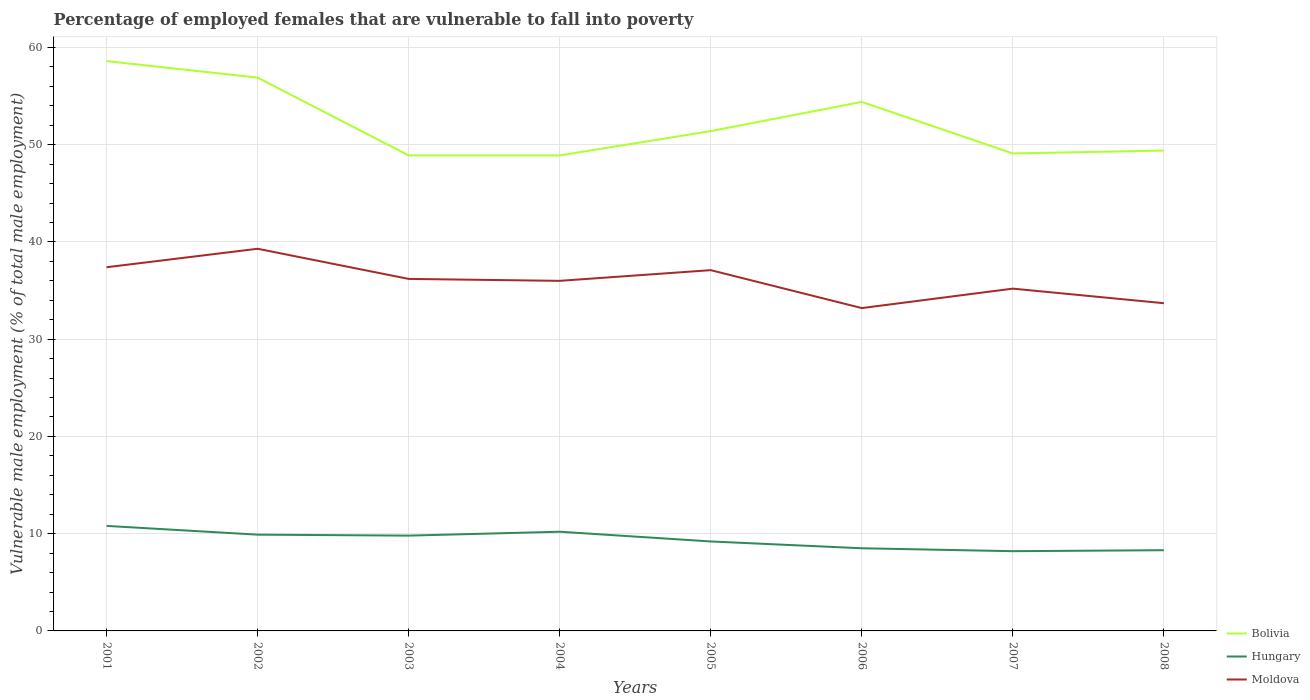Across all years, what is the maximum percentage of employed females who are vulnerable to fall into poverty in Hungary?
Keep it short and to the point. 8.2. In which year was the percentage of employed females who are vulnerable to fall into poverty in Bolivia maximum?
Make the answer very short. 2003. What is the total percentage of employed females who are vulnerable to fall into poverty in Bolivia in the graph?
Your answer should be very brief. 9.7. What is the difference between the highest and the second highest percentage of employed females who are vulnerable to fall into poverty in Moldova?
Your response must be concise. 6.1. What is the difference between the highest and the lowest percentage of employed females who are vulnerable to fall into poverty in Bolivia?
Offer a very short reply. 3. How many lines are there?
Provide a succinct answer. 3. What is the difference between two consecutive major ticks on the Y-axis?
Your answer should be very brief. 10. Are the values on the major ticks of Y-axis written in scientific E-notation?
Offer a very short reply. No. Does the graph contain grids?
Provide a succinct answer. Yes. Where does the legend appear in the graph?
Keep it short and to the point. Bottom right. How many legend labels are there?
Your answer should be very brief. 3. What is the title of the graph?
Keep it short and to the point. Percentage of employed females that are vulnerable to fall into poverty. Does "Bangladesh" appear as one of the legend labels in the graph?
Offer a very short reply. No. What is the label or title of the X-axis?
Provide a succinct answer. Years. What is the label or title of the Y-axis?
Your response must be concise. Vulnerable male employment (% of total male employment). What is the Vulnerable male employment (% of total male employment) of Bolivia in 2001?
Your answer should be very brief. 58.6. What is the Vulnerable male employment (% of total male employment) in Hungary in 2001?
Your response must be concise. 10.8. What is the Vulnerable male employment (% of total male employment) in Moldova in 2001?
Provide a succinct answer. 37.4. What is the Vulnerable male employment (% of total male employment) of Bolivia in 2002?
Offer a very short reply. 56.9. What is the Vulnerable male employment (% of total male employment) of Hungary in 2002?
Offer a very short reply. 9.9. What is the Vulnerable male employment (% of total male employment) of Moldova in 2002?
Offer a very short reply. 39.3. What is the Vulnerable male employment (% of total male employment) of Bolivia in 2003?
Your answer should be compact. 48.9. What is the Vulnerable male employment (% of total male employment) in Hungary in 2003?
Your response must be concise. 9.8. What is the Vulnerable male employment (% of total male employment) in Moldova in 2003?
Provide a short and direct response. 36.2. What is the Vulnerable male employment (% of total male employment) in Bolivia in 2004?
Your answer should be very brief. 48.9. What is the Vulnerable male employment (% of total male employment) of Hungary in 2004?
Keep it short and to the point. 10.2. What is the Vulnerable male employment (% of total male employment) of Bolivia in 2005?
Your answer should be very brief. 51.4. What is the Vulnerable male employment (% of total male employment) in Hungary in 2005?
Keep it short and to the point. 9.2. What is the Vulnerable male employment (% of total male employment) in Moldova in 2005?
Provide a succinct answer. 37.1. What is the Vulnerable male employment (% of total male employment) of Bolivia in 2006?
Provide a short and direct response. 54.4. What is the Vulnerable male employment (% of total male employment) in Hungary in 2006?
Offer a terse response. 8.5. What is the Vulnerable male employment (% of total male employment) in Moldova in 2006?
Your answer should be compact. 33.2. What is the Vulnerable male employment (% of total male employment) in Bolivia in 2007?
Offer a terse response. 49.1. What is the Vulnerable male employment (% of total male employment) in Hungary in 2007?
Offer a very short reply. 8.2. What is the Vulnerable male employment (% of total male employment) in Moldova in 2007?
Your answer should be very brief. 35.2. What is the Vulnerable male employment (% of total male employment) of Bolivia in 2008?
Offer a very short reply. 49.4. What is the Vulnerable male employment (% of total male employment) in Hungary in 2008?
Keep it short and to the point. 8.3. What is the Vulnerable male employment (% of total male employment) of Moldova in 2008?
Your response must be concise. 33.7. Across all years, what is the maximum Vulnerable male employment (% of total male employment) of Bolivia?
Your answer should be very brief. 58.6. Across all years, what is the maximum Vulnerable male employment (% of total male employment) in Hungary?
Your answer should be very brief. 10.8. Across all years, what is the maximum Vulnerable male employment (% of total male employment) in Moldova?
Make the answer very short. 39.3. Across all years, what is the minimum Vulnerable male employment (% of total male employment) in Bolivia?
Provide a succinct answer. 48.9. Across all years, what is the minimum Vulnerable male employment (% of total male employment) in Hungary?
Provide a succinct answer. 8.2. Across all years, what is the minimum Vulnerable male employment (% of total male employment) of Moldova?
Your answer should be very brief. 33.2. What is the total Vulnerable male employment (% of total male employment) in Bolivia in the graph?
Make the answer very short. 417.6. What is the total Vulnerable male employment (% of total male employment) in Hungary in the graph?
Your response must be concise. 74.9. What is the total Vulnerable male employment (% of total male employment) of Moldova in the graph?
Offer a very short reply. 288.1. What is the difference between the Vulnerable male employment (% of total male employment) of Hungary in 2001 and that in 2002?
Your answer should be compact. 0.9. What is the difference between the Vulnerable male employment (% of total male employment) of Hungary in 2001 and that in 2003?
Your response must be concise. 1. What is the difference between the Vulnerable male employment (% of total male employment) of Moldova in 2001 and that in 2003?
Provide a short and direct response. 1.2. What is the difference between the Vulnerable male employment (% of total male employment) in Bolivia in 2001 and that in 2004?
Your response must be concise. 9.7. What is the difference between the Vulnerable male employment (% of total male employment) of Hungary in 2001 and that in 2004?
Keep it short and to the point. 0.6. What is the difference between the Vulnerable male employment (% of total male employment) of Bolivia in 2001 and that in 2005?
Ensure brevity in your answer.  7.2. What is the difference between the Vulnerable male employment (% of total male employment) in Hungary in 2001 and that in 2006?
Ensure brevity in your answer.  2.3. What is the difference between the Vulnerable male employment (% of total male employment) of Moldova in 2001 and that in 2007?
Your answer should be very brief. 2.2. What is the difference between the Vulnerable male employment (% of total male employment) in Moldova in 2001 and that in 2008?
Make the answer very short. 3.7. What is the difference between the Vulnerable male employment (% of total male employment) of Bolivia in 2002 and that in 2004?
Your answer should be compact. 8. What is the difference between the Vulnerable male employment (% of total male employment) in Hungary in 2002 and that in 2004?
Offer a terse response. -0.3. What is the difference between the Vulnerable male employment (% of total male employment) of Moldova in 2002 and that in 2004?
Ensure brevity in your answer.  3.3. What is the difference between the Vulnerable male employment (% of total male employment) in Hungary in 2002 and that in 2005?
Offer a terse response. 0.7. What is the difference between the Vulnerable male employment (% of total male employment) in Moldova in 2002 and that in 2005?
Ensure brevity in your answer.  2.2. What is the difference between the Vulnerable male employment (% of total male employment) of Bolivia in 2002 and that in 2006?
Provide a short and direct response. 2.5. What is the difference between the Vulnerable male employment (% of total male employment) in Moldova in 2002 and that in 2006?
Offer a terse response. 6.1. What is the difference between the Vulnerable male employment (% of total male employment) of Bolivia in 2002 and that in 2007?
Provide a short and direct response. 7.8. What is the difference between the Vulnerable male employment (% of total male employment) in Hungary in 2002 and that in 2007?
Ensure brevity in your answer.  1.7. What is the difference between the Vulnerable male employment (% of total male employment) in Hungary in 2002 and that in 2008?
Your response must be concise. 1.6. What is the difference between the Vulnerable male employment (% of total male employment) in Moldova in 2003 and that in 2004?
Ensure brevity in your answer.  0.2. What is the difference between the Vulnerable male employment (% of total male employment) in Bolivia in 2003 and that in 2005?
Offer a terse response. -2.5. What is the difference between the Vulnerable male employment (% of total male employment) of Hungary in 2003 and that in 2005?
Offer a terse response. 0.6. What is the difference between the Vulnerable male employment (% of total male employment) in Moldova in 2003 and that in 2005?
Offer a terse response. -0.9. What is the difference between the Vulnerable male employment (% of total male employment) of Bolivia in 2003 and that in 2006?
Give a very brief answer. -5.5. What is the difference between the Vulnerable male employment (% of total male employment) in Hungary in 2003 and that in 2007?
Provide a succinct answer. 1.6. What is the difference between the Vulnerable male employment (% of total male employment) of Moldova in 2003 and that in 2007?
Give a very brief answer. 1. What is the difference between the Vulnerable male employment (% of total male employment) in Bolivia in 2003 and that in 2008?
Keep it short and to the point. -0.5. What is the difference between the Vulnerable male employment (% of total male employment) in Hungary in 2003 and that in 2008?
Your response must be concise. 1.5. What is the difference between the Vulnerable male employment (% of total male employment) in Bolivia in 2004 and that in 2005?
Give a very brief answer. -2.5. What is the difference between the Vulnerable male employment (% of total male employment) in Hungary in 2004 and that in 2005?
Your answer should be very brief. 1. What is the difference between the Vulnerable male employment (% of total male employment) of Moldova in 2004 and that in 2005?
Give a very brief answer. -1.1. What is the difference between the Vulnerable male employment (% of total male employment) in Bolivia in 2004 and that in 2006?
Your response must be concise. -5.5. What is the difference between the Vulnerable male employment (% of total male employment) in Hungary in 2004 and that in 2006?
Your response must be concise. 1.7. What is the difference between the Vulnerable male employment (% of total male employment) of Moldova in 2004 and that in 2007?
Your response must be concise. 0.8. What is the difference between the Vulnerable male employment (% of total male employment) of Hungary in 2004 and that in 2008?
Provide a short and direct response. 1.9. What is the difference between the Vulnerable male employment (% of total male employment) of Moldova in 2004 and that in 2008?
Give a very brief answer. 2.3. What is the difference between the Vulnerable male employment (% of total male employment) of Hungary in 2005 and that in 2006?
Your answer should be compact. 0.7. What is the difference between the Vulnerable male employment (% of total male employment) in Moldova in 2005 and that in 2006?
Provide a short and direct response. 3.9. What is the difference between the Vulnerable male employment (% of total male employment) in Hungary in 2005 and that in 2007?
Provide a succinct answer. 1. What is the difference between the Vulnerable male employment (% of total male employment) of Moldova in 2005 and that in 2007?
Offer a very short reply. 1.9. What is the difference between the Vulnerable male employment (% of total male employment) in Hungary in 2005 and that in 2008?
Make the answer very short. 0.9. What is the difference between the Vulnerable male employment (% of total male employment) in Moldova in 2006 and that in 2007?
Give a very brief answer. -2. What is the difference between the Vulnerable male employment (% of total male employment) in Bolivia in 2006 and that in 2008?
Your answer should be compact. 5. What is the difference between the Vulnerable male employment (% of total male employment) of Bolivia in 2007 and that in 2008?
Keep it short and to the point. -0.3. What is the difference between the Vulnerable male employment (% of total male employment) in Bolivia in 2001 and the Vulnerable male employment (% of total male employment) in Hungary in 2002?
Your answer should be very brief. 48.7. What is the difference between the Vulnerable male employment (% of total male employment) in Bolivia in 2001 and the Vulnerable male employment (% of total male employment) in Moldova in 2002?
Make the answer very short. 19.3. What is the difference between the Vulnerable male employment (% of total male employment) in Hungary in 2001 and the Vulnerable male employment (% of total male employment) in Moldova in 2002?
Provide a short and direct response. -28.5. What is the difference between the Vulnerable male employment (% of total male employment) of Bolivia in 2001 and the Vulnerable male employment (% of total male employment) of Hungary in 2003?
Offer a very short reply. 48.8. What is the difference between the Vulnerable male employment (% of total male employment) in Bolivia in 2001 and the Vulnerable male employment (% of total male employment) in Moldova in 2003?
Provide a succinct answer. 22.4. What is the difference between the Vulnerable male employment (% of total male employment) in Hungary in 2001 and the Vulnerable male employment (% of total male employment) in Moldova in 2003?
Provide a short and direct response. -25.4. What is the difference between the Vulnerable male employment (% of total male employment) in Bolivia in 2001 and the Vulnerable male employment (% of total male employment) in Hungary in 2004?
Your answer should be compact. 48.4. What is the difference between the Vulnerable male employment (% of total male employment) in Bolivia in 2001 and the Vulnerable male employment (% of total male employment) in Moldova in 2004?
Keep it short and to the point. 22.6. What is the difference between the Vulnerable male employment (% of total male employment) of Hungary in 2001 and the Vulnerable male employment (% of total male employment) of Moldova in 2004?
Your answer should be very brief. -25.2. What is the difference between the Vulnerable male employment (% of total male employment) in Bolivia in 2001 and the Vulnerable male employment (% of total male employment) in Hungary in 2005?
Your response must be concise. 49.4. What is the difference between the Vulnerable male employment (% of total male employment) of Hungary in 2001 and the Vulnerable male employment (% of total male employment) of Moldova in 2005?
Your response must be concise. -26.3. What is the difference between the Vulnerable male employment (% of total male employment) in Bolivia in 2001 and the Vulnerable male employment (% of total male employment) in Hungary in 2006?
Offer a very short reply. 50.1. What is the difference between the Vulnerable male employment (% of total male employment) in Bolivia in 2001 and the Vulnerable male employment (% of total male employment) in Moldova in 2006?
Keep it short and to the point. 25.4. What is the difference between the Vulnerable male employment (% of total male employment) of Hungary in 2001 and the Vulnerable male employment (% of total male employment) of Moldova in 2006?
Your answer should be very brief. -22.4. What is the difference between the Vulnerable male employment (% of total male employment) of Bolivia in 2001 and the Vulnerable male employment (% of total male employment) of Hungary in 2007?
Offer a very short reply. 50.4. What is the difference between the Vulnerable male employment (% of total male employment) of Bolivia in 2001 and the Vulnerable male employment (% of total male employment) of Moldova in 2007?
Give a very brief answer. 23.4. What is the difference between the Vulnerable male employment (% of total male employment) in Hungary in 2001 and the Vulnerable male employment (% of total male employment) in Moldova in 2007?
Provide a succinct answer. -24.4. What is the difference between the Vulnerable male employment (% of total male employment) of Bolivia in 2001 and the Vulnerable male employment (% of total male employment) of Hungary in 2008?
Your answer should be compact. 50.3. What is the difference between the Vulnerable male employment (% of total male employment) of Bolivia in 2001 and the Vulnerable male employment (% of total male employment) of Moldova in 2008?
Give a very brief answer. 24.9. What is the difference between the Vulnerable male employment (% of total male employment) of Hungary in 2001 and the Vulnerable male employment (% of total male employment) of Moldova in 2008?
Keep it short and to the point. -22.9. What is the difference between the Vulnerable male employment (% of total male employment) in Bolivia in 2002 and the Vulnerable male employment (% of total male employment) in Hungary in 2003?
Ensure brevity in your answer.  47.1. What is the difference between the Vulnerable male employment (% of total male employment) of Bolivia in 2002 and the Vulnerable male employment (% of total male employment) of Moldova in 2003?
Your answer should be compact. 20.7. What is the difference between the Vulnerable male employment (% of total male employment) of Hungary in 2002 and the Vulnerable male employment (% of total male employment) of Moldova in 2003?
Keep it short and to the point. -26.3. What is the difference between the Vulnerable male employment (% of total male employment) of Bolivia in 2002 and the Vulnerable male employment (% of total male employment) of Hungary in 2004?
Offer a very short reply. 46.7. What is the difference between the Vulnerable male employment (% of total male employment) in Bolivia in 2002 and the Vulnerable male employment (% of total male employment) in Moldova in 2004?
Offer a terse response. 20.9. What is the difference between the Vulnerable male employment (% of total male employment) of Hungary in 2002 and the Vulnerable male employment (% of total male employment) of Moldova in 2004?
Provide a succinct answer. -26.1. What is the difference between the Vulnerable male employment (% of total male employment) of Bolivia in 2002 and the Vulnerable male employment (% of total male employment) of Hungary in 2005?
Ensure brevity in your answer.  47.7. What is the difference between the Vulnerable male employment (% of total male employment) in Bolivia in 2002 and the Vulnerable male employment (% of total male employment) in Moldova in 2005?
Your answer should be compact. 19.8. What is the difference between the Vulnerable male employment (% of total male employment) of Hungary in 2002 and the Vulnerable male employment (% of total male employment) of Moldova in 2005?
Give a very brief answer. -27.2. What is the difference between the Vulnerable male employment (% of total male employment) of Bolivia in 2002 and the Vulnerable male employment (% of total male employment) of Hungary in 2006?
Provide a short and direct response. 48.4. What is the difference between the Vulnerable male employment (% of total male employment) of Bolivia in 2002 and the Vulnerable male employment (% of total male employment) of Moldova in 2006?
Your answer should be compact. 23.7. What is the difference between the Vulnerable male employment (% of total male employment) in Hungary in 2002 and the Vulnerable male employment (% of total male employment) in Moldova in 2006?
Your response must be concise. -23.3. What is the difference between the Vulnerable male employment (% of total male employment) of Bolivia in 2002 and the Vulnerable male employment (% of total male employment) of Hungary in 2007?
Provide a short and direct response. 48.7. What is the difference between the Vulnerable male employment (% of total male employment) of Bolivia in 2002 and the Vulnerable male employment (% of total male employment) of Moldova in 2007?
Your response must be concise. 21.7. What is the difference between the Vulnerable male employment (% of total male employment) of Hungary in 2002 and the Vulnerable male employment (% of total male employment) of Moldova in 2007?
Your answer should be compact. -25.3. What is the difference between the Vulnerable male employment (% of total male employment) of Bolivia in 2002 and the Vulnerable male employment (% of total male employment) of Hungary in 2008?
Give a very brief answer. 48.6. What is the difference between the Vulnerable male employment (% of total male employment) of Bolivia in 2002 and the Vulnerable male employment (% of total male employment) of Moldova in 2008?
Make the answer very short. 23.2. What is the difference between the Vulnerable male employment (% of total male employment) in Hungary in 2002 and the Vulnerable male employment (% of total male employment) in Moldova in 2008?
Provide a short and direct response. -23.8. What is the difference between the Vulnerable male employment (% of total male employment) of Bolivia in 2003 and the Vulnerable male employment (% of total male employment) of Hungary in 2004?
Give a very brief answer. 38.7. What is the difference between the Vulnerable male employment (% of total male employment) in Bolivia in 2003 and the Vulnerable male employment (% of total male employment) in Moldova in 2004?
Offer a terse response. 12.9. What is the difference between the Vulnerable male employment (% of total male employment) in Hungary in 2003 and the Vulnerable male employment (% of total male employment) in Moldova in 2004?
Make the answer very short. -26.2. What is the difference between the Vulnerable male employment (% of total male employment) in Bolivia in 2003 and the Vulnerable male employment (% of total male employment) in Hungary in 2005?
Offer a terse response. 39.7. What is the difference between the Vulnerable male employment (% of total male employment) of Hungary in 2003 and the Vulnerable male employment (% of total male employment) of Moldova in 2005?
Provide a short and direct response. -27.3. What is the difference between the Vulnerable male employment (% of total male employment) in Bolivia in 2003 and the Vulnerable male employment (% of total male employment) in Hungary in 2006?
Offer a very short reply. 40.4. What is the difference between the Vulnerable male employment (% of total male employment) in Bolivia in 2003 and the Vulnerable male employment (% of total male employment) in Moldova in 2006?
Ensure brevity in your answer.  15.7. What is the difference between the Vulnerable male employment (% of total male employment) in Hungary in 2003 and the Vulnerable male employment (% of total male employment) in Moldova in 2006?
Give a very brief answer. -23.4. What is the difference between the Vulnerable male employment (% of total male employment) in Bolivia in 2003 and the Vulnerable male employment (% of total male employment) in Hungary in 2007?
Ensure brevity in your answer.  40.7. What is the difference between the Vulnerable male employment (% of total male employment) in Hungary in 2003 and the Vulnerable male employment (% of total male employment) in Moldova in 2007?
Keep it short and to the point. -25.4. What is the difference between the Vulnerable male employment (% of total male employment) in Bolivia in 2003 and the Vulnerable male employment (% of total male employment) in Hungary in 2008?
Make the answer very short. 40.6. What is the difference between the Vulnerable male employment (% of total male employment) of Bolivia in 2003 and the Vulnerable male employment (% of total male employment) of Moldova in 2008?
Give a very brief answer. 15.2. What is the difference between the Vulnerable male employment (% of total male employment) in Hungary in 2003 and the Vulnerable male employment (% of total male employment) in Moldova in 2008?
Your answer should be compact. -23.9. What is the difference between the Vulnerable male employment (% of total male employment) of Bolivia in 2004 and the Vulnerable male employment (% of total male employment) of Hungary in 2005?
Your response must be concise. 39.7. What is the difference between the Vulnerable male employment (% of total male employment) in Bolivia in 2004 and the Vulnerable male employment (% of total male employment) in Moldova in 2005?
Give a very brief answer. 11.8. What is the difference between the Vulnerable male employment (% of total male employment) in Hungary in 2004 and the Vulnerable male employment (% of total male employment) in Moldova in 2005?
Give a very brief answer. -26.9. What is the difference between the Vulnerable male employment (% of total male employment) of Bolivia in 2004 and the Vulnerable male employment (% of total male employment) of Hungary in 2006?
Ensure brevity in your answer.  40.4. What is the difference between the Vulnerable male employment (% of total male employment) of Bolivia in 2004 and the Vulnerable male employment (% of total male employment) of Moldova in 2006?
Make the answer very short. 15.7. What is the difference between the Vulnerable male employment (% of total male employment) in Bolivia in 2004 and the Vulnerable male employment (% of total male employment) in Hungary in 2007?
Your answer should be very brief. 40.7. What is the difference between the Vulnerable male employment (% of total male employment) of Bolivia in 2004 and the Vulnerable male employment (% of total male employment) of Moldova in 2007?
Provide a short and direct response. 13.7. What is the difference between the Vulnerable male employment (% of total male employment) in Hungary in 2004 and the Vulnerable male employment (% of total male employment) in Moldova in 2007?
Offer a very short reply. -25. What is the difference between the Vulnerable male employment (% of total male employment) in Bolivia in 2004 and the Vulnerable male employment (% of total male employment) in Hungary in 2008?
Provide a short and direct response. 40.6. What is the difference between the Vulnerable male employment (% of total male employment) of Bolivia in 2004 and the Vulnerable male employment (% of total male employment) of Moldova in 2008?
Your response must be concise. 15.2. What is the difference between the Vulnerable male employment (% of total male employment) in Hungary in 2004 and the Vulnerable male employment (% of total male employment) in Moldova in 2008?
Provide a succinct answer. -23.5. What is the difference between the Vulnerable male employment (% of total male employment) of Bolivia in 2005 and the Vulnerable male employment (% of total male employment) of Hungary in 2006?
Your answer should be very brief. 42.9. What is the difference between the Vulnerable male employment (% of total male employment) of Hungary in 2005 and the Vulnerable male employment (% of total male employment) of Moldova in 2006?
Provide a succinct answer. -24. What is the difference between the Vulnerable male employment (% of total male employment) in Bolivia in 2005 and the Vulnerable male employment (% of total male employment) in Hungary in 2007?
Make the answer very short. 43.2. What is the difference between the Vulnerable male employment (% of total male employment) in Bolivia in 2005 and the Vulnerable male employment (% of total male employment) in Moldova in 2007?
Provide a short and direct response. 16.2. What is the difference between the Vulnerable male employment (% of total male employment) in Hungary in 2005 and the Vulnerable male employment (% of total male employment) in Moldova in 2007?
Your response must be concise. -26. What is the difference between the Vulnerable male employment (% of total male employment) of Bolivia in 2005 and the Vulnerable male employment (% of total male employment) of Hungary in 2008?
Provide a short and direct response. 43.1. What is the difference between the Vulnerable male employment (% of total male employment) in Hungary in 2005 and the Vulnerable male employment (% of total male employment) in Moldova in 2008?
Provide a succinct answer. -24.5. What is the difference between the Vulnerable male employment (% of total male employment) in Bolivia in 2006 and the Vulnerable male employment (% of total male employment) in Hungary in 2007?
Keep it short and to the point. 46.2. What is the difference between the Vulnerable male employment (% of total male employment) of Hungary in 2006 and the Vulnerable male employment (% of total male employment) of Moldova in 2007?
Provide a succinct answer. -26.7. What is the difference between the Vulnerable male employment (% of total male employment) in Bolivia in 2006 and the Vulnerable male employment (% of total male employment) in Hungary in 2008?
Your answer should be very brief. 46.1. What is the difference between the Vulnerable male employment (% of total male employment) in Bolivia in 2006 and the Vulnerable male employment (% of total male employment) in Moldova in 2008?
Your answer should be very brief. 20.7. What is the difference between the Vulnerable male employment (% of total male employment) in Hungary in 2006 and the Vulnerable male employment (% of total male employment) in Moldova in 2008?
Provide a succinct answer. -25.2. What is the difference between the Vulnerable male employment (% of total male employment) of Bolivia in 2007 and the Vulnerable male employment (% of total male employment) of Hungary in 2008?
Provide a succinct answer. 40.8. What is the difference between the Vulnerable male employment (% of total male employment) in Hungary in 2007 and the Vulnerable male employment (% of total male employment) in Moldova in 2008?
Your answer should be compact. -25.5. What is the average Vulnerable male employment (% of total male employment) of Bolivia per year?
Provide a succinct answer. 52.2. What is the average Vulnerable male employment (% of total male employment) in Hungary per year?
Offer a very short reply. 9.36. What is the average Vulnerable male employment (% of total male employment) in Moldova per year?
Provide a succinct answer. 36.01. In the year 2001, what is the difference between the Vulnerable male employment (% of total male employment) of Bolivia and Vulnerable male employment (% of total male employment) of Hungary?
Keep it short and to the point. 47.8. In the year 2001, what is the difference between the Vulnerable male employment (% of total male employment) in Bolivia and Vulnerable male employment (% of total male employment) in Moldova?
Offer a terse response. 21.2. In the year 2001, what is the difference between the Vulnerable male employment (% of total male employment) in Hungary and Vulnerable male employment (% of total male employment) in Moldova?
Give a very brief answer. -26.6. In the year 2002, what is the difference between the Vulnerable male employment (% of total male employment) in Bolivia and Vulnerable male employment (% of total male employment) in Hungary?
Provide a succinct answer. 47. In the year 2002, what is the difference between the Vulnerable male employment (% of total male employment) of Bolivia and Vulnerable male employment (% of total male employment) of Moldova?
Keep it short and to the point. 17.6. In the year 2002, what is the difference between the Vulnerable male employment (% of total male employment) in Hungary and Vulnerable male employment (% of total male employment) in Moldova?
Offer a very short reply. -29.4. In the year 2003, what is the difference between the Vulnerable male employment (% of total male employment) in Bolivia and Vulnerable male employment (% of total male employment) in Hungary?
Provide a short and direct response. 39.1. In the year 2003, what is the difference between the Vulnerable male employment (% of total male employment) in Bolivia and Vulnerable male employment (% of total male employment) in Moldova?
Provide a succinct answer. 12.7. In the year 2003, what is the difference between the Vulnerable male employment (% of total male employment) of Hungary and Vulnerable male employment (% of total male employment) of Moldova?
Your response must be concise. -26.4. In the year 2004, what is the difference between the Vulnerable male employment (% of total male employment) in Bolivia and Vulnerable male employment (% of total male employment) in Hungary?
Your answer should be very brief. 38.7. In the year 2004, what is the difference between the Vulnerable male employment (% of total male employment) of Hungary and Vulnerable male employment (% of total male employment) of Moldova?
Provide a succinct answer. -25.8. In the year 2005, what is the difference between the Vulnerable male employment (% of total male employment) of Bolivia and Vulnerable male employment (% of total male employment) of Hungary?
Make the answer very short. 42.2. In the year 2005, what is the difference between the Vulnerable male employment (% of total male employment) in Bolivia and Vulnerable male employment (% of total male employment) in Moldova?
Give a very brief answer. 14.3. In the year 2005, what is the difference between the Vulnerable male employment (% of total male employment) of Hungary and Vulnerable male employment (% of total male employment) of Moldova?
Your answer should be very brief. -27.9. In the year 2006, what is the difference between the Vulnerable male employment (% of total male employment) in Bolivia and Vulnerable male employment (% of total male employment) in Hungary?
Keep it short and to the point. 45.9. In the year 2006, what is the difference between the Vulnerable male employment (% of total male employment) in Bolivia and Vulnerable male employment (% of total male employment) in Moldova?
Offer a very short reply. 21.2. In the year 2006, what is the difference between the Vulnerable male employment (% of total male employment) in Hungary and Vulnerable male employment (% of total male employment) in Moldova?
Give a very brief answer. -24.7. In the year 2007, what is the difference between the Vulnerable male employment (% of total male employment) of Bolivia and Vulnerable male employment (% of total male employment) of Hungary?
Give a very brief answer. 40.9. In the year 2008, what is the difference between the Vulnerable male employment (% of total male employment) in Bolivia and Vulnerable male employment (% of total male employment) in Hungary?
Make the answer very short. 41.1. In the year 2008, what is the difference between the Vulnerable male employment (% of total male employment) in Hungary and Vulnerable male employment (% of total male employment) in Moldova?
Keep it short and to the point. -25.4. What is the ratio of the Vulnerable male employment (% of total male employment) of Bolivia in 2001 to that in 2002?
Ensure brevity in your answer.  1.03. What is the ratio of the Vulnerable male employment (% of total male employment) in Moldova in 2001 to that in 2002?
Offer a very short reply. 0.95. What is the ratio of the Vulnerable male employment (% of total male employment) in Bolivia in 2001 to that in 2003?
Ensure brevity in your answer.  1.2. What is the ratio of the Vulnerable male employment (% of total male employment) in Hungary in 2001 to that in 2003?
Keep it short and to the point. 1.1. What is the ratio of the Vulnerable male employment (% of total male employment) in Moldova in 2001 to that in 2003?
Offer a terse response. 1.03. What is the ratio of the Vulnerable male employment (% of total male employment) of Bolivia in 2001 to that in 2004?
Your answer should be very brief. 1.2. What is the ratio of the Vulnerable male employment (% of total male employment) of Hungary in 2001 to that in 2004?
Ensure brevity in your answer.  1.06. What is the ratio of the Vulnerable male employment (% of total male employment) in Moldova in 2001 to that in 2004?
Provide a succinct answer. 1.04. What is the ratio of the Vulnerable male employment (% of total male employment) of Bolivia in 2001 to that in 2005?
Keep it short and to the point. 1.14. What is the ratio of the Vulnerable male employment (% of total male employment) of Hungary in 2001 to that in 2005?
Offer a very short reply. 1.17. What is the ratio of the Vulnerable male employment (% of total male employment) of Moldova in 2001 to that in 2005?
Give a very brief answer. 1.01. What is the ratio of the Vulnerable male employment (% of total male employment) of Bolivia in 2001 to that in 2006?
Provide a short and direct response. 1.08. What is the ratio of the Vulnerable male employment (% of total male employment) of Hungary in 2001 to that in 2006?
Offer a very short reply. 1.27. What is the ratio of the Vulnerable male employment (% of total male employment) of Moldova in 2001 to that in 2006?
Ensure brevity in your answer.  1.13. What is the ratio of the Vulnerable male employment (% of total male employment) of Bolivia in 2001 to that in 2007?
Provide a short and direct response. 1.19. What is the ratio of the Vulnerable male employment (% of total male employment) in Hungary in 2001 to that in 2007?
Ensure brevity in your answer.  1.32. What is the ratio of the Vulnerable male employment (% of total male employment) of Moldova in 2001 to that in 2007?
Offer a very short reply. 1.06. What is the ratio of the Vulnerable male employment (% of total male employment) in Bolivia in 2001 to that in 2008?
Offer a very short reply. 1.19. What is the ratio of the Vulnerable male employment (% of total male employment) of Hungary in 2001 to that in 2008?
Keep it short and to the point. 1.3. What is the ratio of the Vulnerable male employment (% of total male employment) of Moldova in 2001 to that in 2008?
Offer a terse response. 1.11. What is the ratio of the Vulnerable male employment (% of total male employment) of Bolivia in 2002 to that in 2003?
Provide a short and direct response. 1.16. What is the ratio of the Vulnerable male employment (% of total male employment) of Hungary in 2002 to that in 2003?
Your answer should be compact. 1.01. What is the ratio of the Vulnerable male employment (% of total male employment) in Moldova in 2002 to that in 2003?
Keep it short and to the point. 1.09. What is the ratio of the Vulnerable male employment (% of total male employment) of Bolivia in 2002 to that in 2004?
Give a very brief answer. 1.16. What is the ratio of the Vulnerable male employment (% of total male employment) in Hungary in 2002 to that in 2004?
Offer a terse response. 0.97. What is the ratio of the Vulnerable male employment (% of total male employment) in Moldova in 2002 to that in 2004?
Your response must be concise. 1.09. What is the ratio of the Vulnerable male employment (% of total male employment) in Bolivia in 2002 to that in 2005?
Ensure brevity in your answer.  1.11. What is the ratio of the Vulnerable male employment (% of total male employment) in Hungary in 2002 to that in 2005?
Offer a terse response. 1.08. What is the ratio of the Vulnerable male employment (% of total male employment) in Moldova in 2002 to that in 2005?
Your answer should be very brief. 1.06. What is the ratio of the Vulnerable male employment (% of total male employment) in Bolivia in 2002 to that in 2006?
Your response must be concise. 1.05. What is the ratio of the Vulnerable male employment (% of total male employment) of Hungary in 2002 to that in 2006?
Your response must be concise. 1.16. What is the ratio of the Vulnerable male employment (% of total male employment) in Moldova in 2002 to that in 2006?
Make the answer very short. 1.18. What is the ratio of the Vulnerable male employment (% of total male employment) of Bolivia in 2002 to that in 2007?
Offer a terse response. 1.16. What is the ratio of the Vulnerable male employment (% of total male employment) in Hungary in 2002 to that in 2007?
Keep it short and to the point. 1.21. What is the ratio of the Vulnerable male employment (% of total male employment) of Moldova in 2002 to that in 2007?
Make the answer very short. 1.12. What is the ratio of the Vulnerable male employment (% of total male employment) of Bolivia in 2002 to that in 2008?
Your response must be concise. 1.15. What is the ratio of the Vulnerable male employment (% of total male employment) of Hungary in 2002 to that in 2008?
Make the answer very short. 1.19. What is the ratio of the Vulnerable male employment (% of total male employment) in Moldova in 2002 to that in 2008?
Your answer should be compact. 1.17. What is the ratio of the Vulnerable male employment (% of total male employment) in Bolivia in 2003 to that in 2004?
Make the answer very short. 1. What is the ratio of the Vulnerable male employment (% of total male employment) of Hungary in 2003 to that in 2004?
Keep it short and to the point. 0.96. What is the ratio of the Vulnerable male employment (% of total male employment) of Moldova in 2003 to that in 2004?
Keep it short and to the point. 1.01. What is the ratio of the Vulnerable male employment (% of total male employment) of Bolivia in 2003 to that in 2005?
Offer a terse response. 0.95. What is the ratio of the Vulnerable male employment (% of total male employment) in Hungary in 2003 to that in 2005?
Offer a very short reply. 1.07. What is the ratio of the Vulnerable male employment (% of total male employment) of Moldova in 2003 to that in 2005?
Make the answer very short. 0.98. What is the ratio of the Vulnerable male employment (% of total male employment) of Bolivia in 2003 to that in 2006?
Your answer should be very brief. 0.9. What is the ratio of the Vulnerable male employment (% of total male employment) of Hungary in 2003 to that in 2006?
Give a very brief answer. 1.15. What is the ratio of the Vulnerable male employment (% of total male employment) of Moldova in 2003 to that in 2006?
Provide a short and direct response. 1.09. What is the ratio of the Vulnerable male employment (% of total male employment) in Hungary in 2003 to that in 2007?
Provide a succinct answer. 1.2. What is the ratio of the Vulnerable male employment (% of total male employment) of Moldova in 2003 to that in 2007?
Provide a succinct answer. 1.03. What is the ratio of the Vulnerable male employment (% of total male employment) in Bolivia in 2003 to that in 2008?
Give a very brief answer. 0.99. What is the ratio of the Vulnerable male employment (% of total male employment) of Hungary in 2003 to that in 2008?
Make the answer very short. 1.18. What is the ratio of the Vulnerable male employment (% of total male employment) in Moldova in 2003 to that in 2008?
Provide a short and direct response. 1.07. What is the ratio of the Vulnerable male employment (% of total male employment) of Bolivia in 2004 to that in 2005?
Keep it short and to the point. 0.95. What is the ratio of the Vulnerable male employment (% of total male employment) in Hungary in 2004 to that in 2005?
Provide a succinct answer. 1.11. What is the ratio of the Vulnerable male employment (% of total male employment) in Moldova in 2004 to that in 2005?
Your answer should be very brief. 0.97. What is the ratio of the Vulnerable male employment (% of total male employment) of Bolivia in 2004 to that in 2006?
Offer a very short reply. 0.9. What is the ratio of the Vulnerable male employment (% of total male employment) of Hungary in 2004 to that in 2006?
Make the answer very short. 1.2. What is the ratio of the Vulnerable male employment (% of total male employment) of Moldova in 2004 to that in 2006?
Provide a succinct answer. 1.08. What is the ratio of the Vulnerable male employment (% of total male employment) in Hungary in 2004 to that in 2007?
Your answer should be very brief. 1.24. What is the ratio of the Vulnerable male employment (% of total male employment) in Moldova in 2004 to that in 2007?
Give a very brief answer. 1.02. What is the ratio of the Vulnerable male employment (% of total male employment) of Bolivia in 2004 to that in 2008?
Your response must be concise. 0.99. What is the ratio of the Vulnerable male employment (% of total male employment) in Hungary in 2004 to that in 2008?
Make the answer very short. 1.23. What is the ratio of the Vulnerable male employment (% of total male employment) in Moldova in 2004 to that in 2008?
Provide a short and direct response. 1.07. What is the ratio of the Vulnerable male employment (% of total male employment) of Bolivia in 2005 to that in 2006?
Offer a very short reply. 0.94. What is the ratio of the Vulnerable male employment (% of total male employment) in Hungary in 2005 to that in 2006?
Provide a succinct answer. 1.08. What is the ratio of the Vulnerable male employment (% of total male employment) of Moldova in 2005 to that in 2006?
Ensure brevity in your answer.  1.12. What is the ratio of the Vulnerable male employment (% of total male employment) of Bolivia in 2005 to that in 2007?
Your answer should be very brief. 1.05. What is the ratio of the Vulnerable male employment (% of total male employment) in Hungary in 2005 to that in 2007?
Make the answer very short. 1.12. What is the ratio of the Vulnerable male employment (% of total male employment) of Moldova in 2005 to that in 2007?
Offer a terse response. 1.05. What is the ratio of the Vulnerable male employment (% of total male employment) in Bolivia in 2005 to that in 2008?
Provide a succinct answer. 1.04. What is the ratio of the Vulnerable male employment (% of total male employment) in Hungary in 2005 to that in 2008?
Your answer should be compact. 1.11. What is the ratio of the Vulnerable male employment (% of total male employment) in Moldova in 2005 to that in 2008?
Offer a terse response. 1.1. What is the ratio of the Vulnerable male employment (% of total male employment) in Bolivia in 2006 to that in 2007?
Your answer should be compact. 1.11. What is the ratio of the Vulnerable male employment (% of total male employment) of Hungary in 2006 to that in 2007?
Offer a very short reply. 1.04. What is the ratio of the Vulnerable male employment (% of total male employment) of Moldova in 2006 to that in 2007?
Keep it short and to the point. 0.94. What is the ratio of the Vulnerable male employment (% of total male employment) in Bolivia in 2006 to that in 2008?
Make the answer very short. 1.1. What is the ratio of the Vulnerable male employment (% of total male employment) of Hungary in 2006 to that in 2008?
Offer a terse response. 1.02. What is the ratio of the Vulnerable male employment (% of total male employment) in Moldova in 2006 to that in 2008?
Ensure brevity in your answer.  0.99. What is the ratio of the Vulnerable male employment (% of total male employment) of Bolivia in 2007 to that in 2008?
Your answer should be very brief. 0.99. What is the ratio of the Vulnerable male employment (% of total male employment) in Hungary in 2007 to that in 2008?
Keep it short and to the point. 0.99. What is the ratio of the Vulnerable male employment (% of total male employment) in Moldova in 2007 to that in 2008?
Provide a short and direct response. 1.04. What is the difference between the highest and the second highest Vulnerable male employment (% of total male employment) in Bolivia?
Ensure brevity in your answer.  1.7. What is the difference between the highest and the lowest Vulnerable male employment (% of total male employment) in Hungary?
Offer a very short reply. 2.6. 